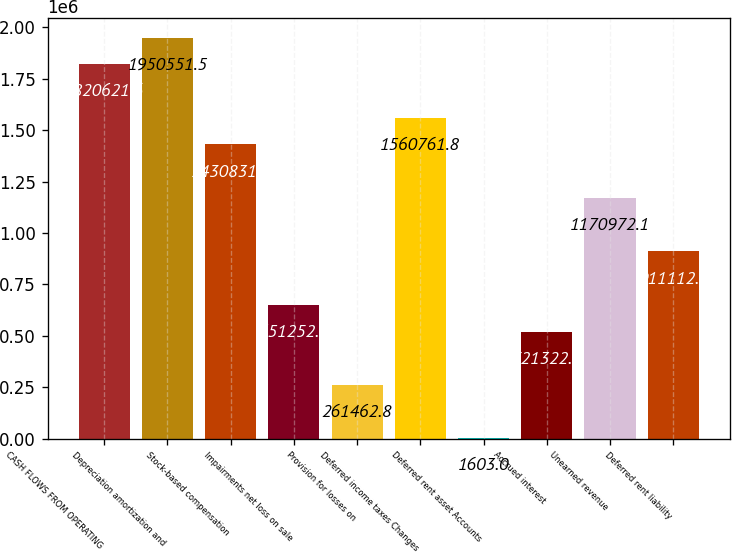Convert chart to OTSL. <chart><loc_0><loc_0><loc_500><loc_500><bar_chart><fcel>CASH FLOWS FROM OPERATING<fcel>Depreciation amortization and<fcel>Stock-based compensation<fcel>Impairments net loss on sale<fcel>Provision for losses on<fcel>Deferred income taxes Changes<fcel>Deferred rent asset Accounts<fcel>Accrued interest<fcel>Unearned revenue<fcel>Deferred rent liability<nl><fcel>1.82062e+06<fcel>1.95055e+06<fcel>1.43083e+06<fcel>651252<fcel>261463<fcel>1.56076e+06<fcel>1603<fcel>521323<fcel>1.17097e+06<fcel>911112<nl></chart> 